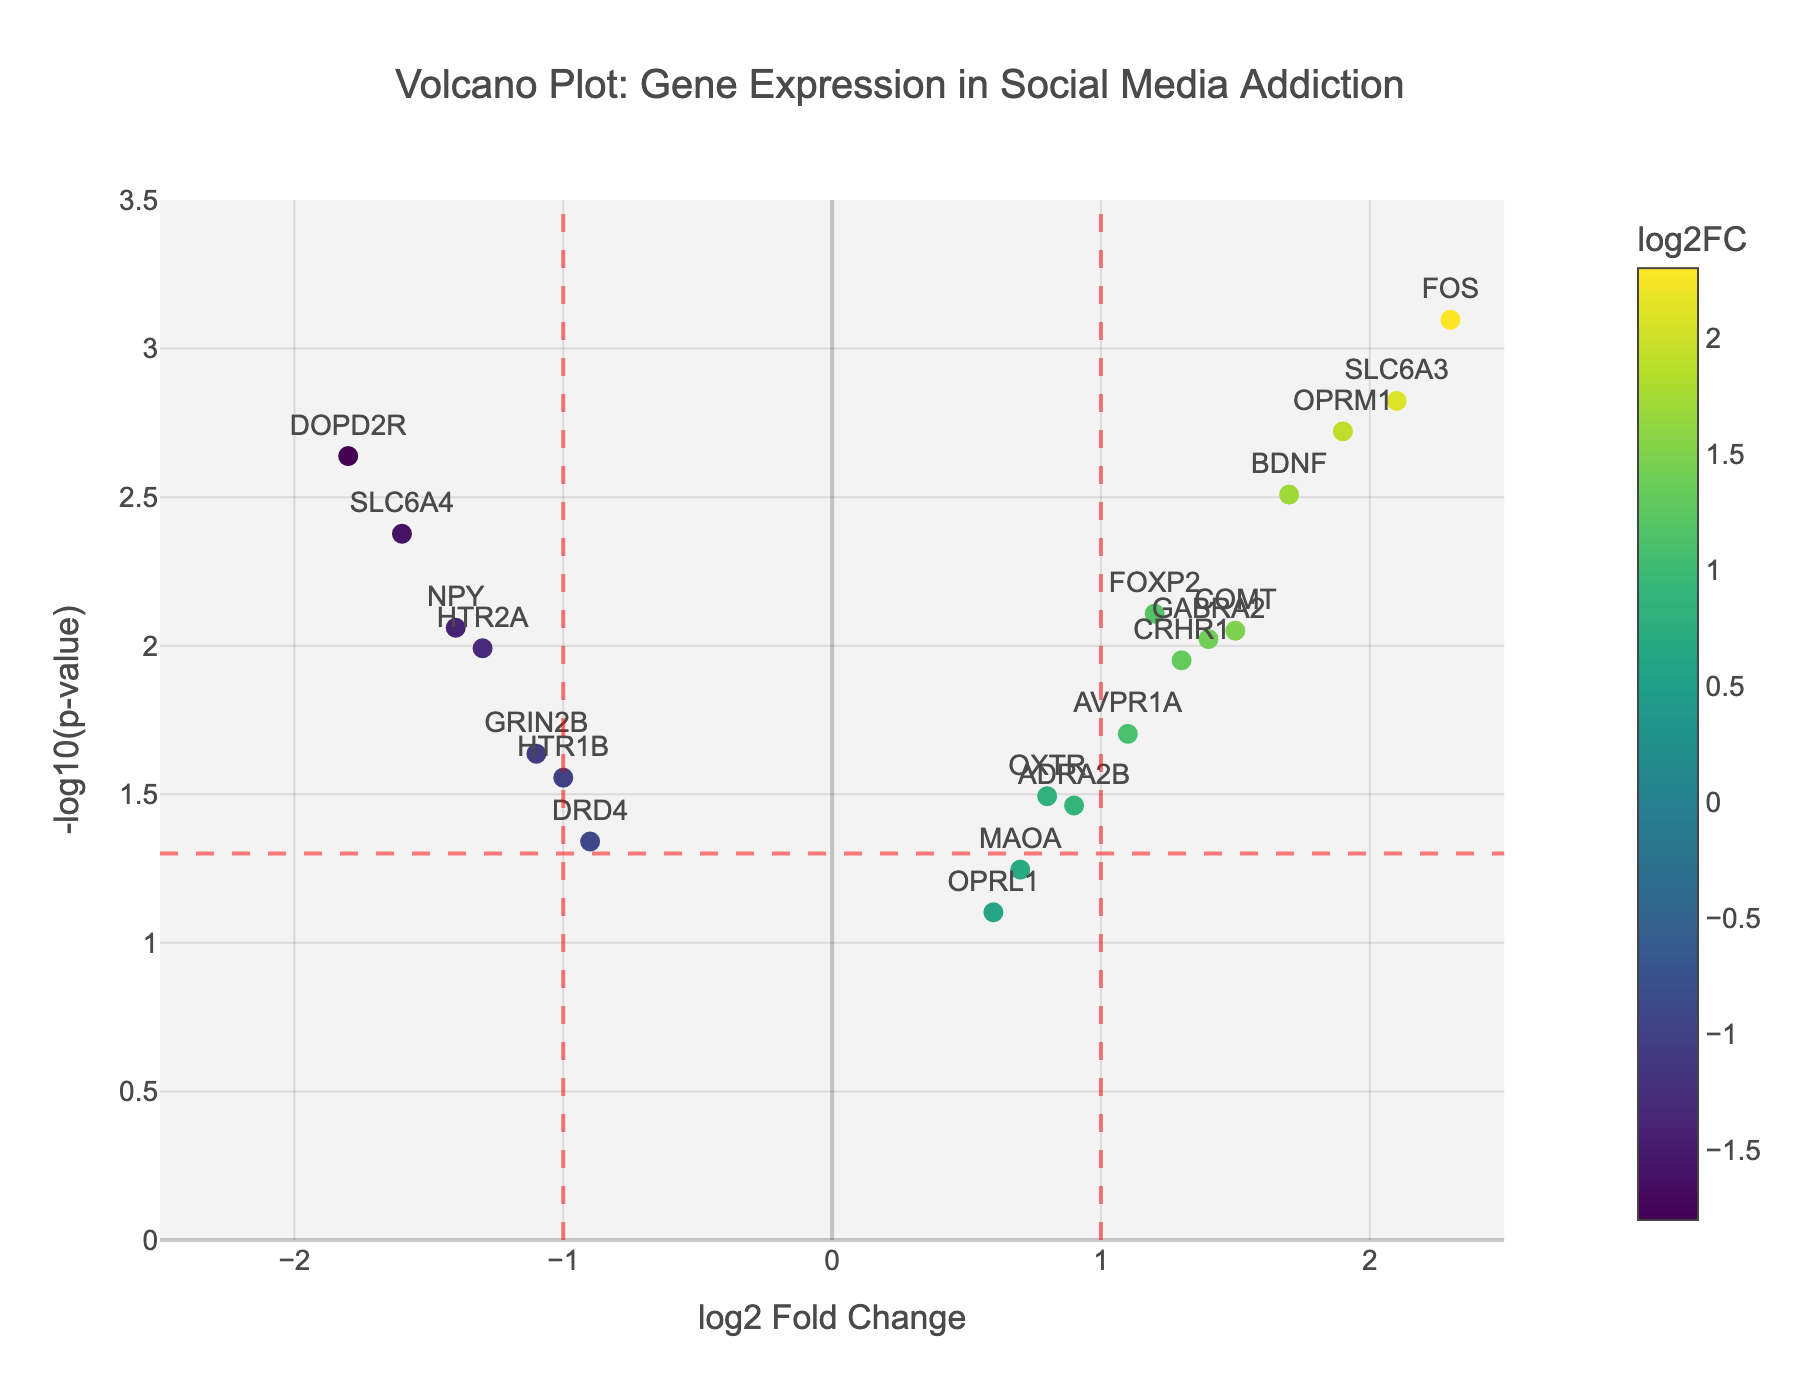What is the gene with the highest log2 Fold Change? The gene with the highest log2 Fold Change can be identified by locating the point on the x-axis farthest to the right. The corresponding gene label is FOS.
Answer: FOS Which gene has the smallest p-value? The gene with the smallest p-value can be found by identifying the point with the highest value on the y-axis. The corresponding gene label is FOS.
Answer: FOS How many genes have a -log10(p-value) greater than 2? Genes with a -log10(p-value) greater than 2 are positioned above the y=2 line. Count the number of points above this line: DOPD2R, SLC6A3, BDNF, OPRM1, and FOS.
Answer: 5 Which gene has the greatest negative log2 Fold Change? The gene with the greatest negative log2 Fold Change can be identified by locating the point on the x-axis farthest to the left. The corresponding gene label is DOPD2R.
Answer: DOPD2R Which genes have both log2 Fold Change values greater than 1 and -log10(p-value) greater than 1.3? To identify these genes, look for points that are to the right of the x=1 line and above the y=1.3 line. These points are SLC6A3, BDNF, OPRM1, and FOS.
Answer: SLC6A3, BDNF, OPRM1, FOS What are the genes with p-values less than 0.05? Genes with p-values less than 0.05 are those that lie above the y = -log10(0.05) line. The points above those lines represent DOPD2R, SLC6A3, COMT, DRD4, FOXP2, BDNF, HTR2A, SLC6A4, OPRM1, FOS, GRIN2B, NPY, CRHR1, and GABRA2.
Answer: DOPD2R, SLC6A3, COMT, DRD4, FOXP2, BDNF, HTR2A, SLC6A4, OPRM1, FOS, GRIN2B, NPY, CRHR1, GABRA2 Which gene has the lowest -log10(p-value)? The gene with the lowest -log10(p-value) can be found by identifying the point with the smallest value on the y-axis. The corresponding gene label is OPRL1.
Answer: OPRL1 How many genes have a log2 Fold Change greater than 1? Look for the points to the right of the x=1 line and count them. These points are SLC6A3, BDNF, OPRM1, and FOS.
Answer: 4 What is the -log10(p-value) for SLC6A3? SLC6A3 is labeled in the figure. Its y-axis value represents -log10(p-value). Calculate -log10(0.0015) which is approximately 2.82.
Answer: 2.82 